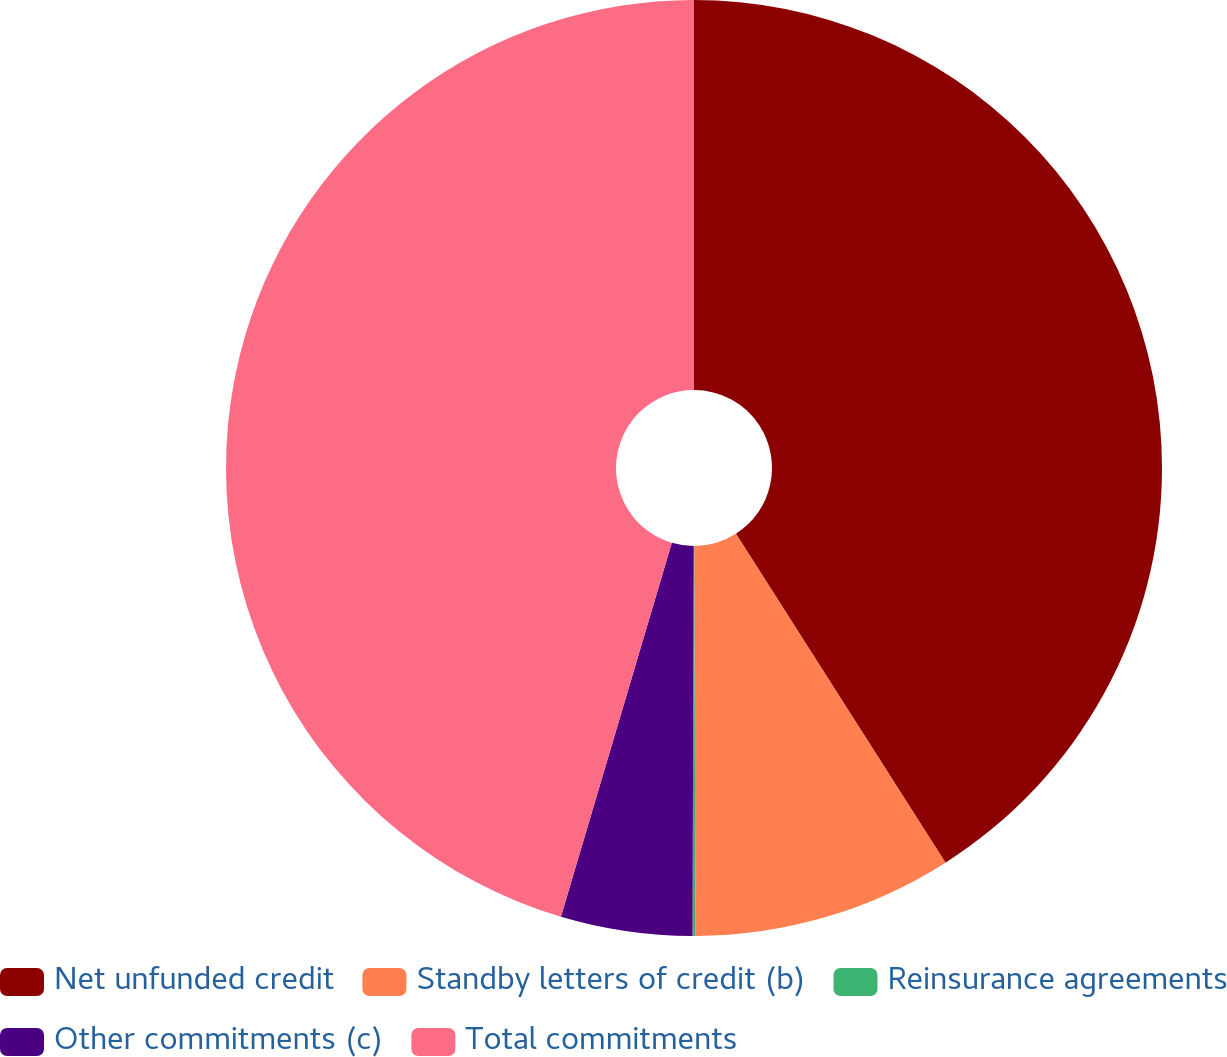Convert chart. <chart><loc_0><loc_0><loc_500><loc_500><pie_chart><fcel>Net unfunded credit<fcel>Standby letters of credit (b)<fcel>Reinsurance agreements<fcel>Other commitments (c)<fcel>Total commitments<nl><fcel>40.97%<fcel>8.98%<fcel>0.1%<fcel>4.54%<fcel>45.41%<nl></chart> 